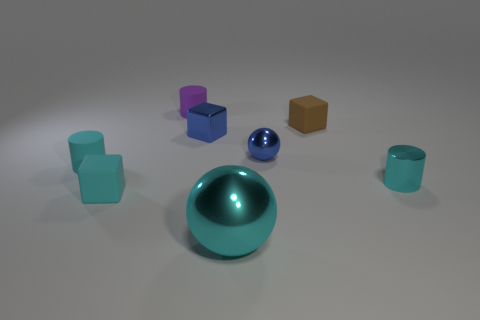Add 1 matte cubes. How many objects exist? 9 Subtract all balls. How many objects are left? 6 Add 5 blue rubber spheres. How many blue rubber spheres exist? 5 Subtract 1 blue spheres. How many objects are left? 7 Subtract all shiny objects. Subtract all cyan blocks. How many objects are left? 3 Add 7 tiny purple things. How many tiny purple things are left? 8 